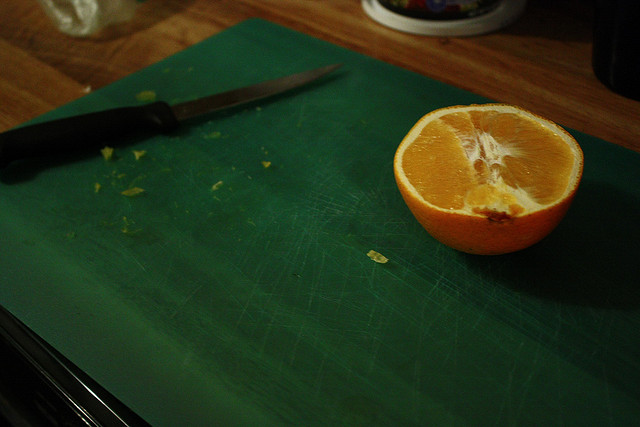What are the nutritional benefits of consuming Navel oranges? Navel oranges are rich in vitamin C, fiber, and contain antioxidants. They support immune function, digestive health, and can contribute to overall heart health. 